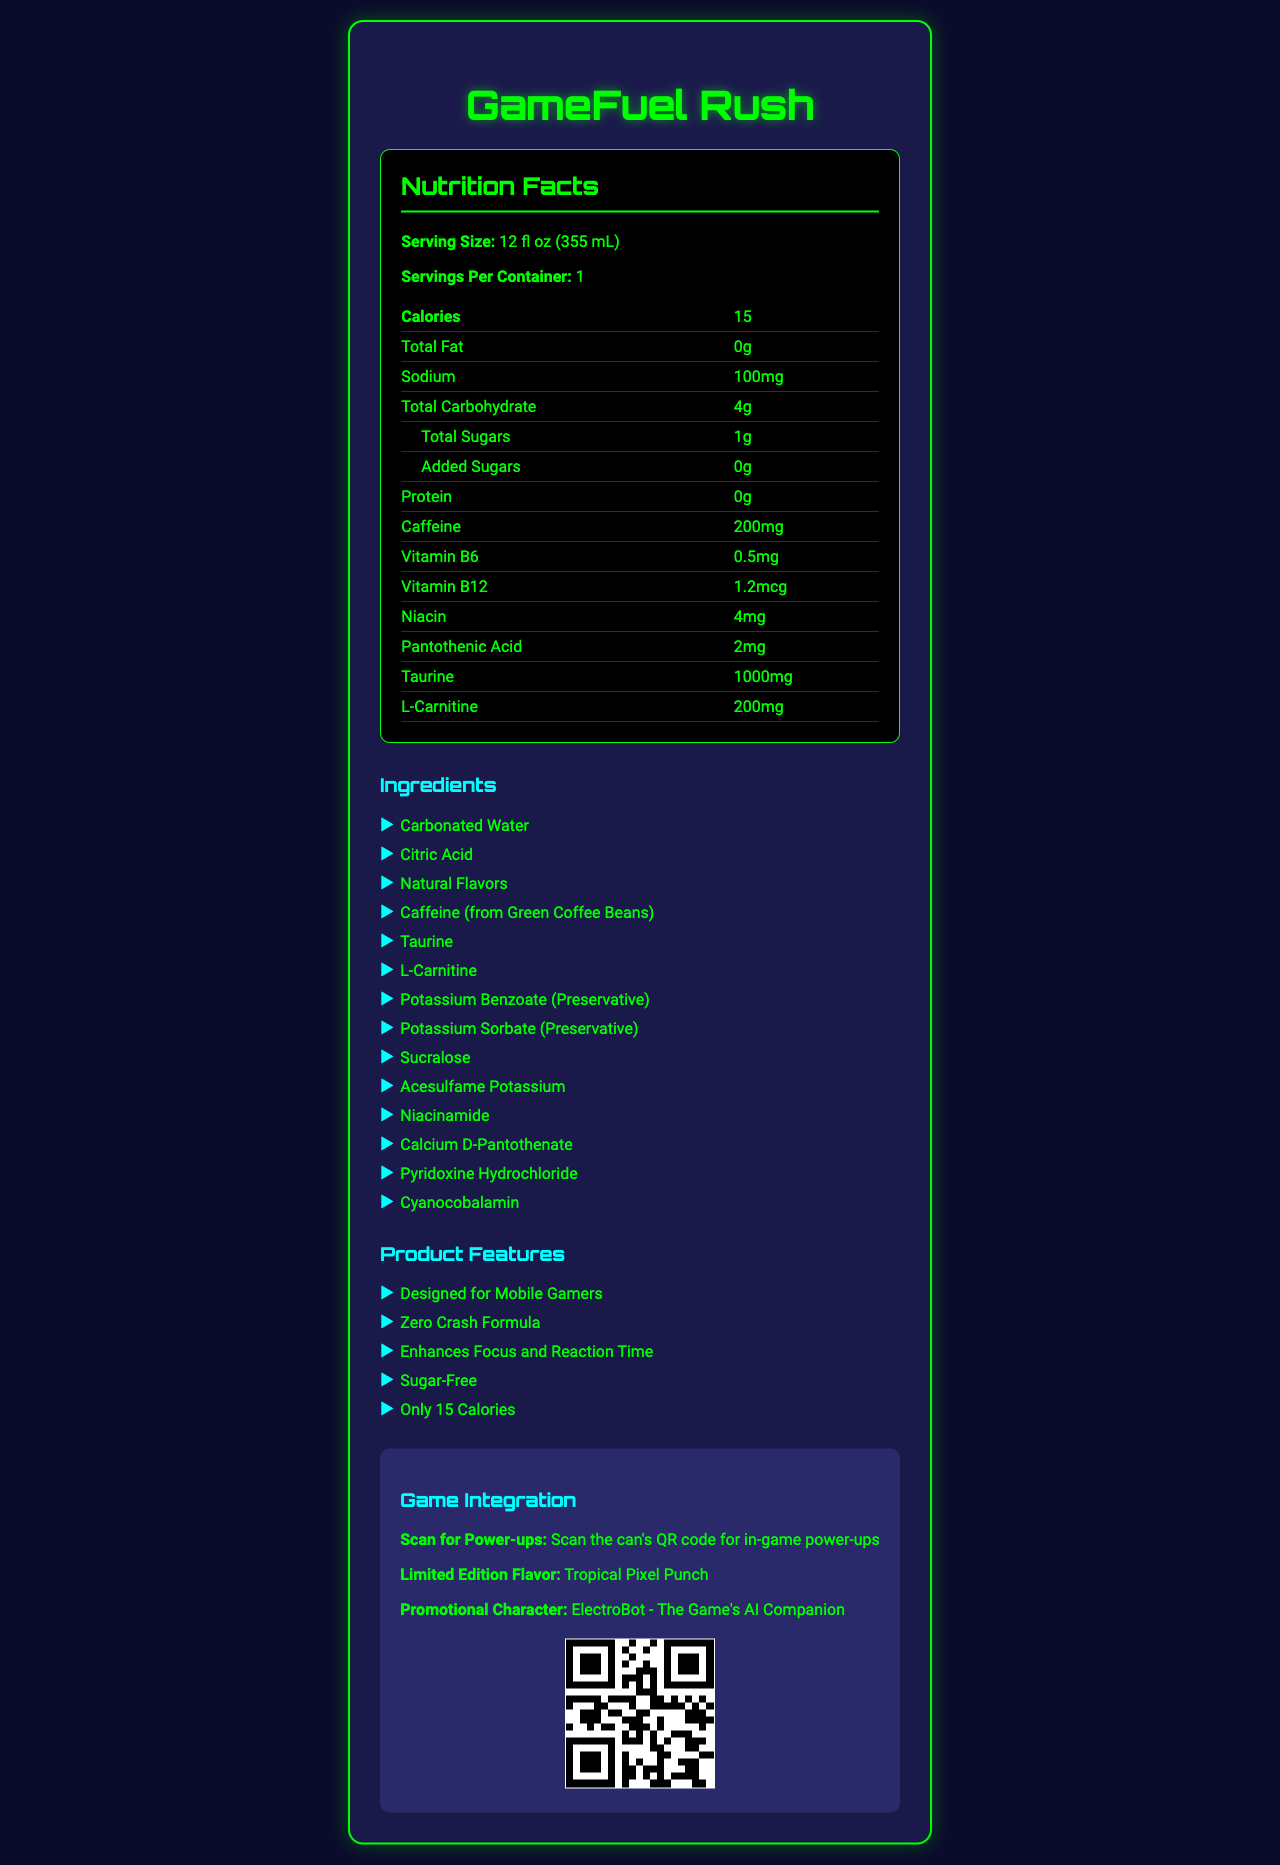what is the serving size of GameFuel Rush? The serving size is specified at the top of the Nutrition Facts section.
Answer: 12 fl oz (355 mL) how many calories are in one serving of GameFuel Rush? The document lists 15 calories per serving in the Nutrition Facts table.
Answer: 15 how much caffeine does one serving contain? The caffeine content per serving is listed as 200mg in the Nutrition Facts table.
Answer: 200mg what are the total sugars per serving? The total sugars per serving is listed as 1g in the Nutrition Facts table.
Answer: 1g how much sodium is in one serving? The sodium content per serving is listed as 100mg in the Nutrition Facts table.
Answer: 100mg how many grams of protein are in one serving of GameFuel Rush? The protein content per serving is listed as 0g in the Nutrition Facts table.
Answer: 0g which vitamin is present in the highest quantity per serving? A. Vitamin B6 B. Vitamin B12 C. Niacin D. Pantothenic Acid Niacin is present in the highest quantity per serving at 4mg, as shown in the Nutrition Facts table.
Answer: C. Niacin what is the promotional character for GameFuel Rush? A. CyberNinja B. ElectroBot C. MegaMage D. PowerPal The promotional character listed in the Game Integration section is ElectroBot.
Answer: B. ElectroBot is GameFuel Rush a sugar-free beverage? The marketing claims section states "Sugar-Free", indicating the beverage is sugar-free.
Answer: Yes what is the total fat content per serving? The Nutrition Facts table lists total fat content per serving as 0g.
Answer: 0g does GameFuel Rush contain any artificial preservatives? The ingredients list includes Potassium Benzoate and Potassium Sorbate, which are artificial preservatives.
Answer: Yes how does GameFuel Rush support mobile gamers? The marketing claims include enhancing focus and reaction time, which supports mobile gamers.
Answer: Enhances Focus and Reaction Time what ingredient is used for sweetness in GameFuel Rush? The ingredients list includes Sucralose and Acesulfame Potassium, which are artificial sweeteners.
Answer: Sucralose, Acesulfame Potassium can you get in-game power-ups with GameFuel Rush? The Game Integration section mentions scanning the can's QR code for in-game power-ups.
Answer: Yes what is GameFuel Rush's limited edition flavor? The limited edition flavor listed in the Game Integration section is Tropical Pixel Punch.
Answer: Tropical Pixel Punch describe the main idea of the document. The document combines the nutritional breakdown, marketing claims, and game integration features to attract mobile gamers to GameFuel Rush.
Answer: GameFuel Rush is a low-sugar, high-caffeine beverage designed for mobile gamers, with features such as enhancing focus and reaction time, and providing in-game power-ups through a QR code. It's sugar-free, contains only 15 calories per serving, and includes several vitamins and amino acids to support gamers. what are the health effects of taurine included in GameFuel Rush? The document lists taurine as an ingredient and its quantity, but does not provide specific health effects.
Answer: Cannot be determined 